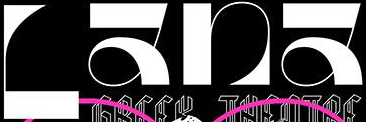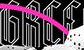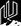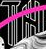What words can you see in these images in sequence, separated by a semicolon? Lana; GRCC; #; TH 